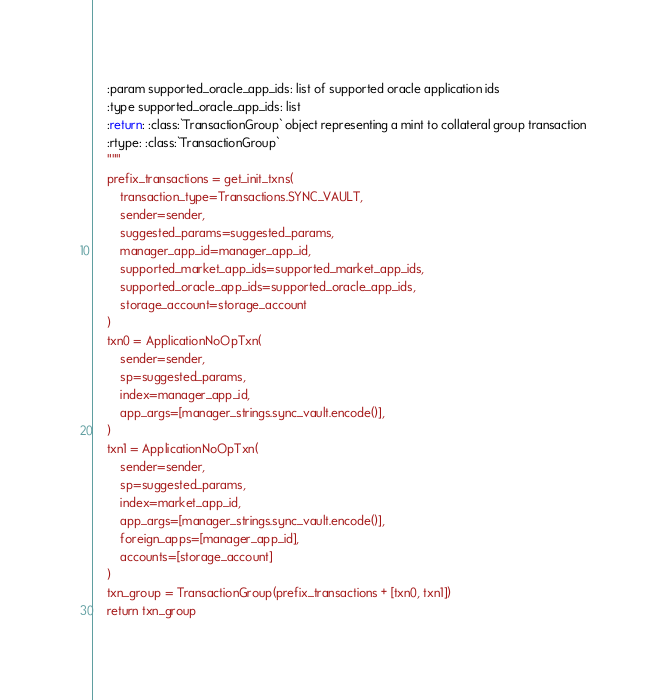Convert code to text. <code><loc_0><loc_0><loc_500><loc_500><_Python_>    :param supported_oracle_app_ids: list of supported oracle application ids
    :type supported_oracle_app_ids: list
    :return: :class:`TransactionGroup` object representing a mint to collateral group transaction
    :rtype: :class:`TransactionGroup`
    """
    prefix_transactions = get_init_txns(
        transaction_type=Transactions.SYNC_VAULT,
        sender=sender,
        suggested_params=suggested_params,
        manager_app_id=manager_app_id,
        supported_market_app_ids=supported_market_app_ids,
        supported_oracle_app_ids=supported_oracle_app_ids,
        storage_account=storage_account
    )
    txn0 = ApplicationNoOpTxn(
        sender=sender,
        sp=suggested_params,
        index=manager_app_id,
        app_args=[manager_strings.sync_vault.encode()],
    )
    txn1 = ApplicationNoOpTxn(
        sender=sender,
        sp=suggested_params,
        index=market_app_id,
        app_args=[manager_strings.sync_vault.encode()],
        foreign_apps=[manager_app_id],
        accounts=[storage_account]
    )
    txn_group = TransactionGroup(prefix_transactions + [txn0, txn1])
    return txn_group</code> 